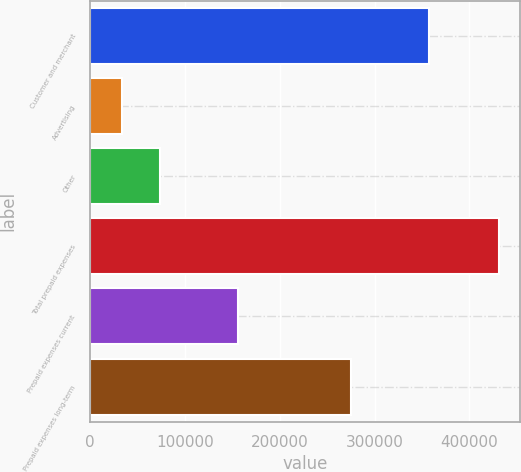Convert chart. <chart><loc_0><loc_0><loc_500><loc_500><bar_chart><fcel>Customer and merchant<fcel>Advertising<fcel>Other<fcel>Total prepaid expenses<fcel>Prepaid expenses current<fcel>Prepaid expenses long-term<nl><fcel>357761<fcel>33603<fcel>73364.7<fcel>431220<fcel>156258<fcel>274962<nl></chart> 